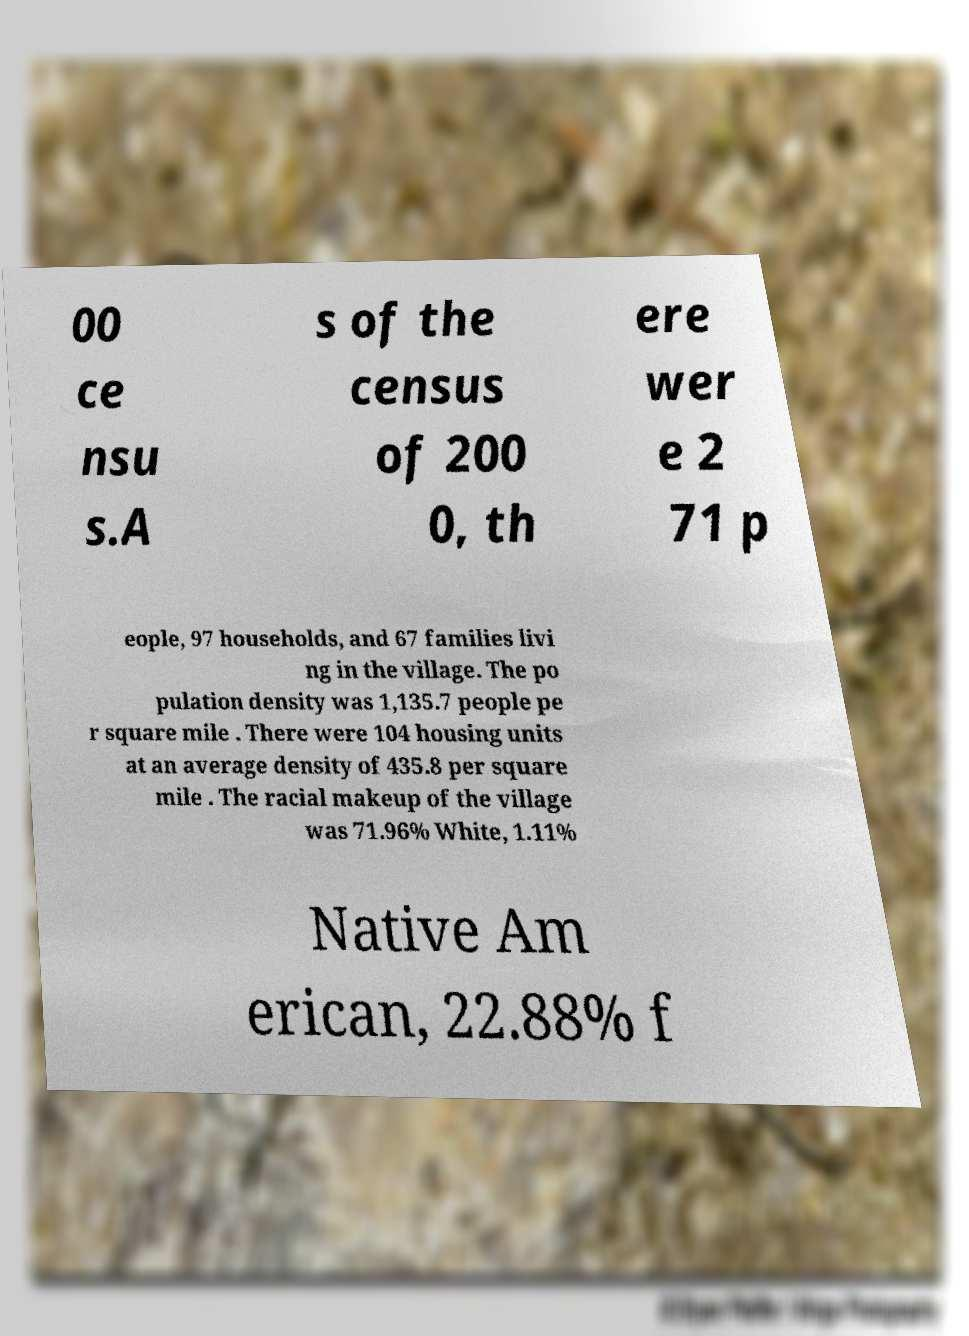Could you extract and type out the text from this image? 00 ce nsu s.A s of the census of 200 0, th ere wer e 2 71 p eople, 97 households, and 67 families livi ng in the village. The po pulation density was 1,135.7 people pe r square mile . There were 104 housing units at an average density of 435.8 per square mile . The racial makeup of the village was 71.96% White, 1.11% Native Am erican, 22.88% f 